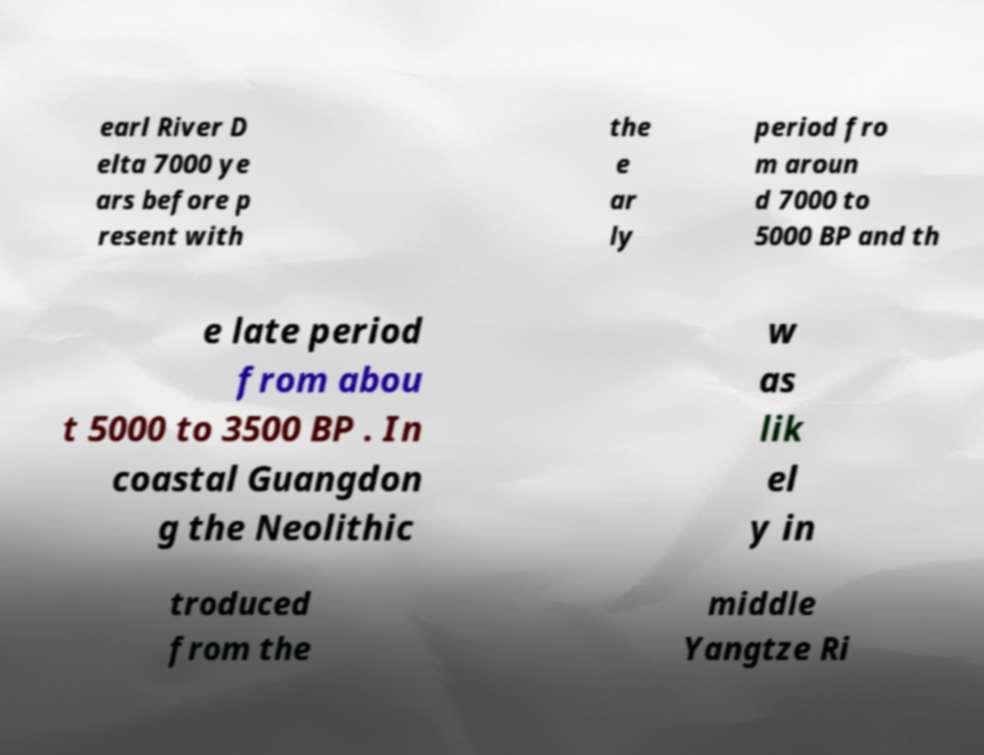What messages or text are displayed in this image? I need them in a readable, typed format. earl River D elta 7000 ye ars before p resent with the e ar ly period fro m aroun d 7000 to 5000 BP and th e late period from abou t 5000 to 3500 BP . In coastal Guangdon g the Neolithic w as lik el y in troduced from the middle Yangtze Ri 